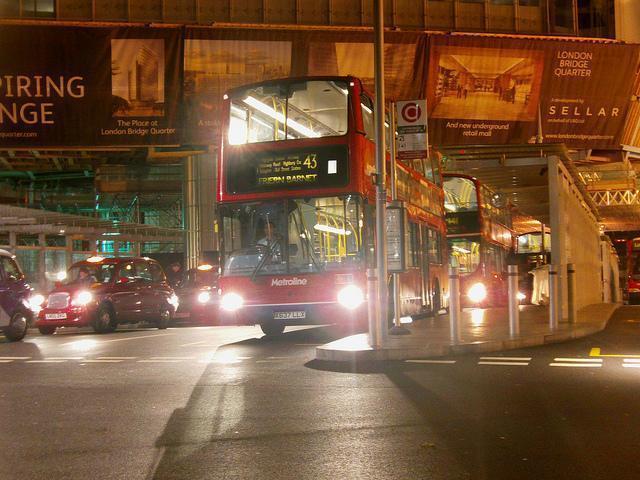What country is it?
Select the accurate response from the four choices given to answer the question.
Options: Spain, britain, france, italy. Britain. 